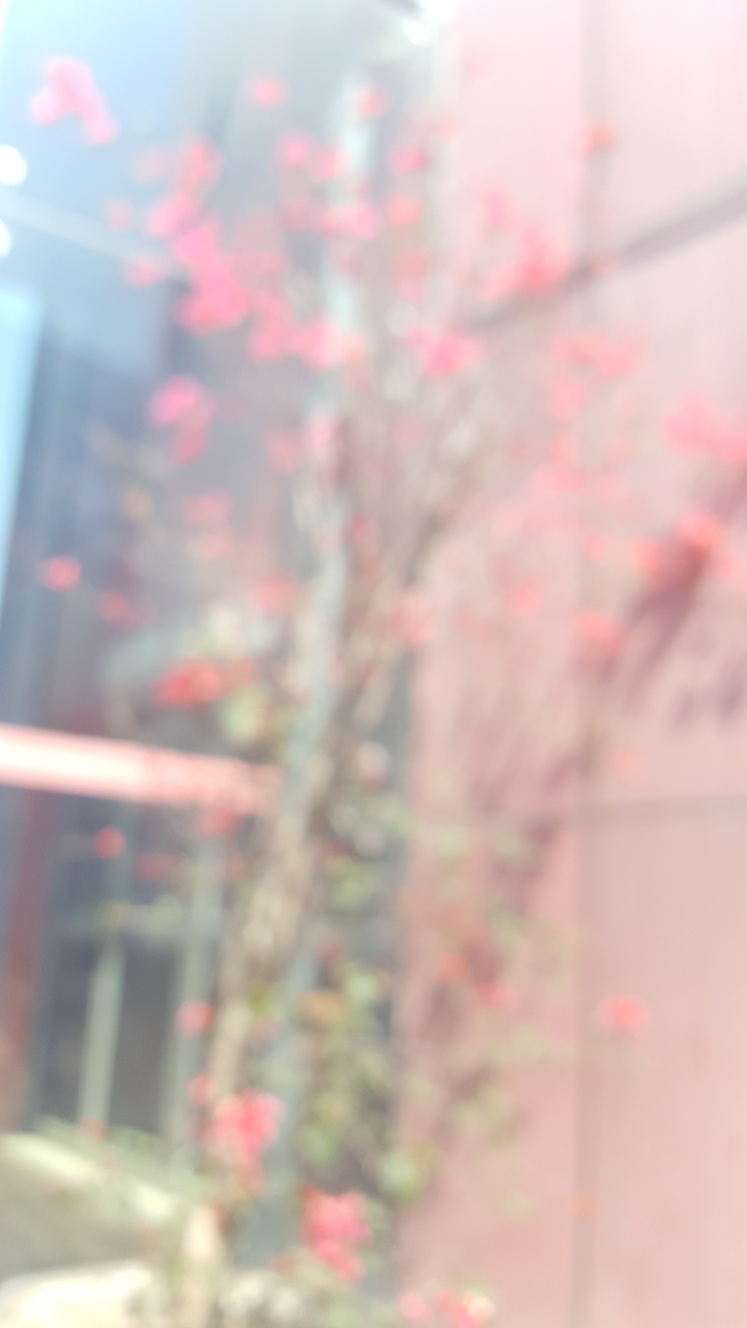Does the image capture a tree? Yes, the image does capture a tree. You can observe the branches extending across the frame with blossoms that suggest it may be spring. The vibrant pink flowers stand out against a blurred background, indicating the tree is the main focus of this photograph. 